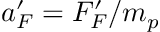Convert formula to latex. <formula><loc_0><loc_0><loc_500><loc_500>a _ { F } ^ { \prime } = F _ { F } ^ { \prime } / m _ { p }</formula> 